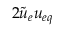<formula> <loc_0><loc_0><loc_500><loc_500>2 \tilde { u } _ { e } u _ { e q }</formula> 